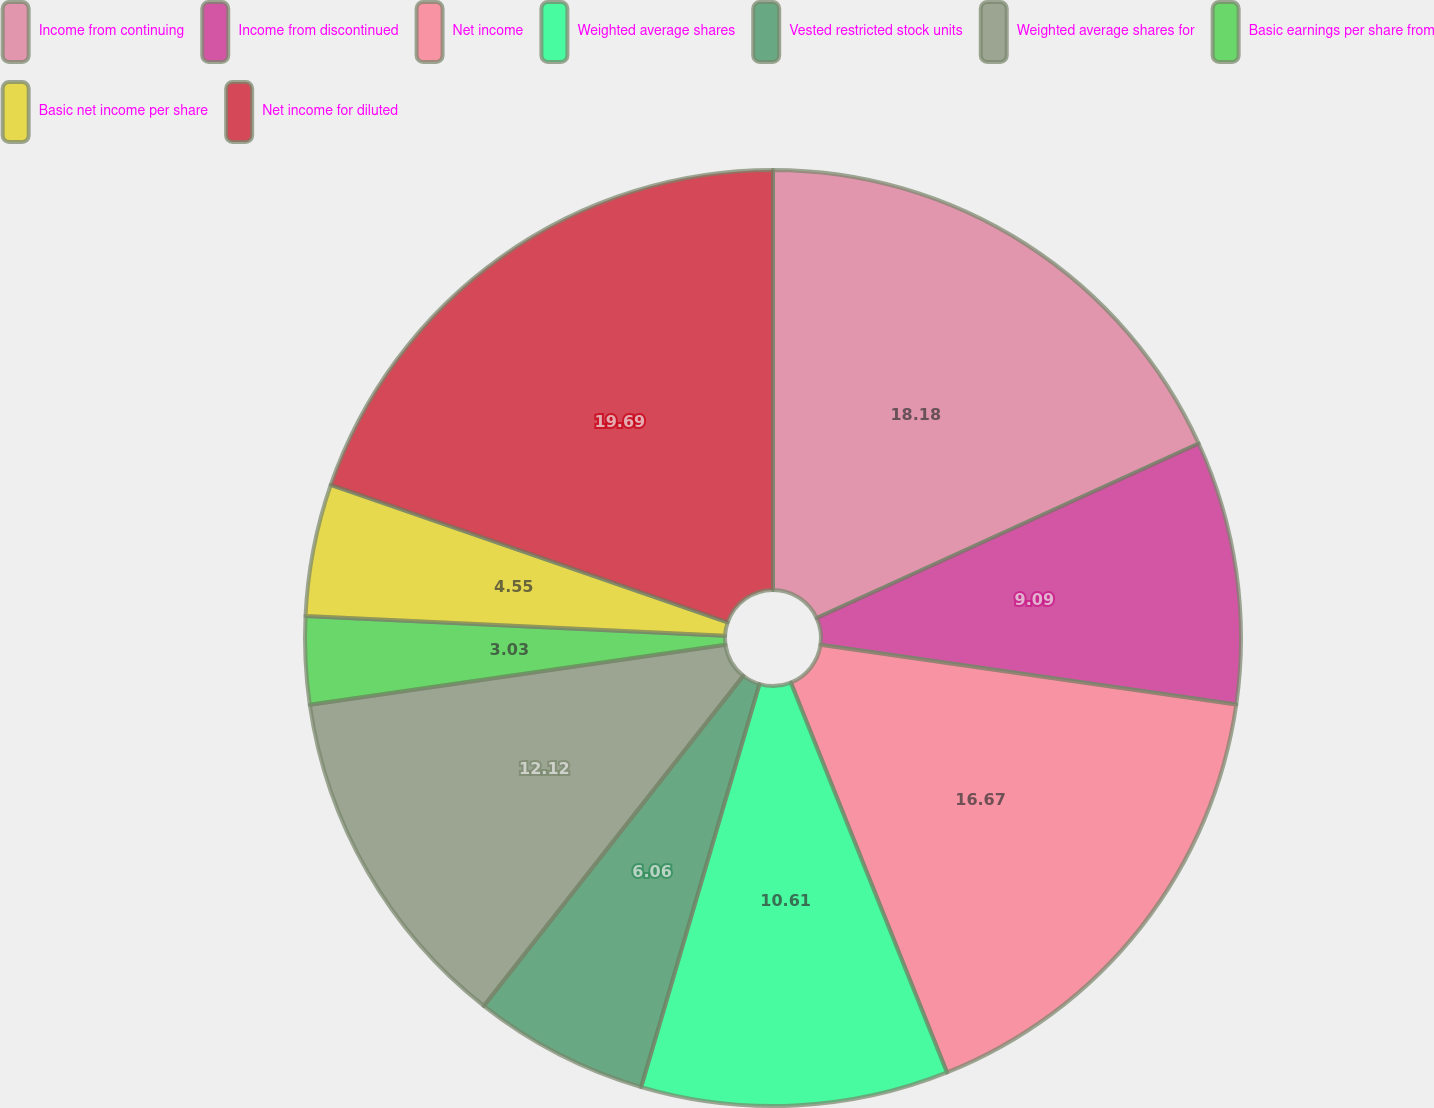<chart> <loc_0><loc_0><loc_500><loc_500><pie_chart><fcel>Income from continuing<fcel>Income from discontinued<fcel>Net income<fcel>Weighted average shares<fcel>Vested restricted stock units<fcel>Weighted average shares for<fcel>Basic earnings per share from<fcel>Basic net income per share<fcel>Net income for diluted<nl><fcel>18.18%<fcel>9.09%<fcel>16.67%<fcel>10.61%<fcel>6.06%<fcel>12.12%<fcel>3.03%<fcel>4.55%<fcel>19.7%<nl></chart> 